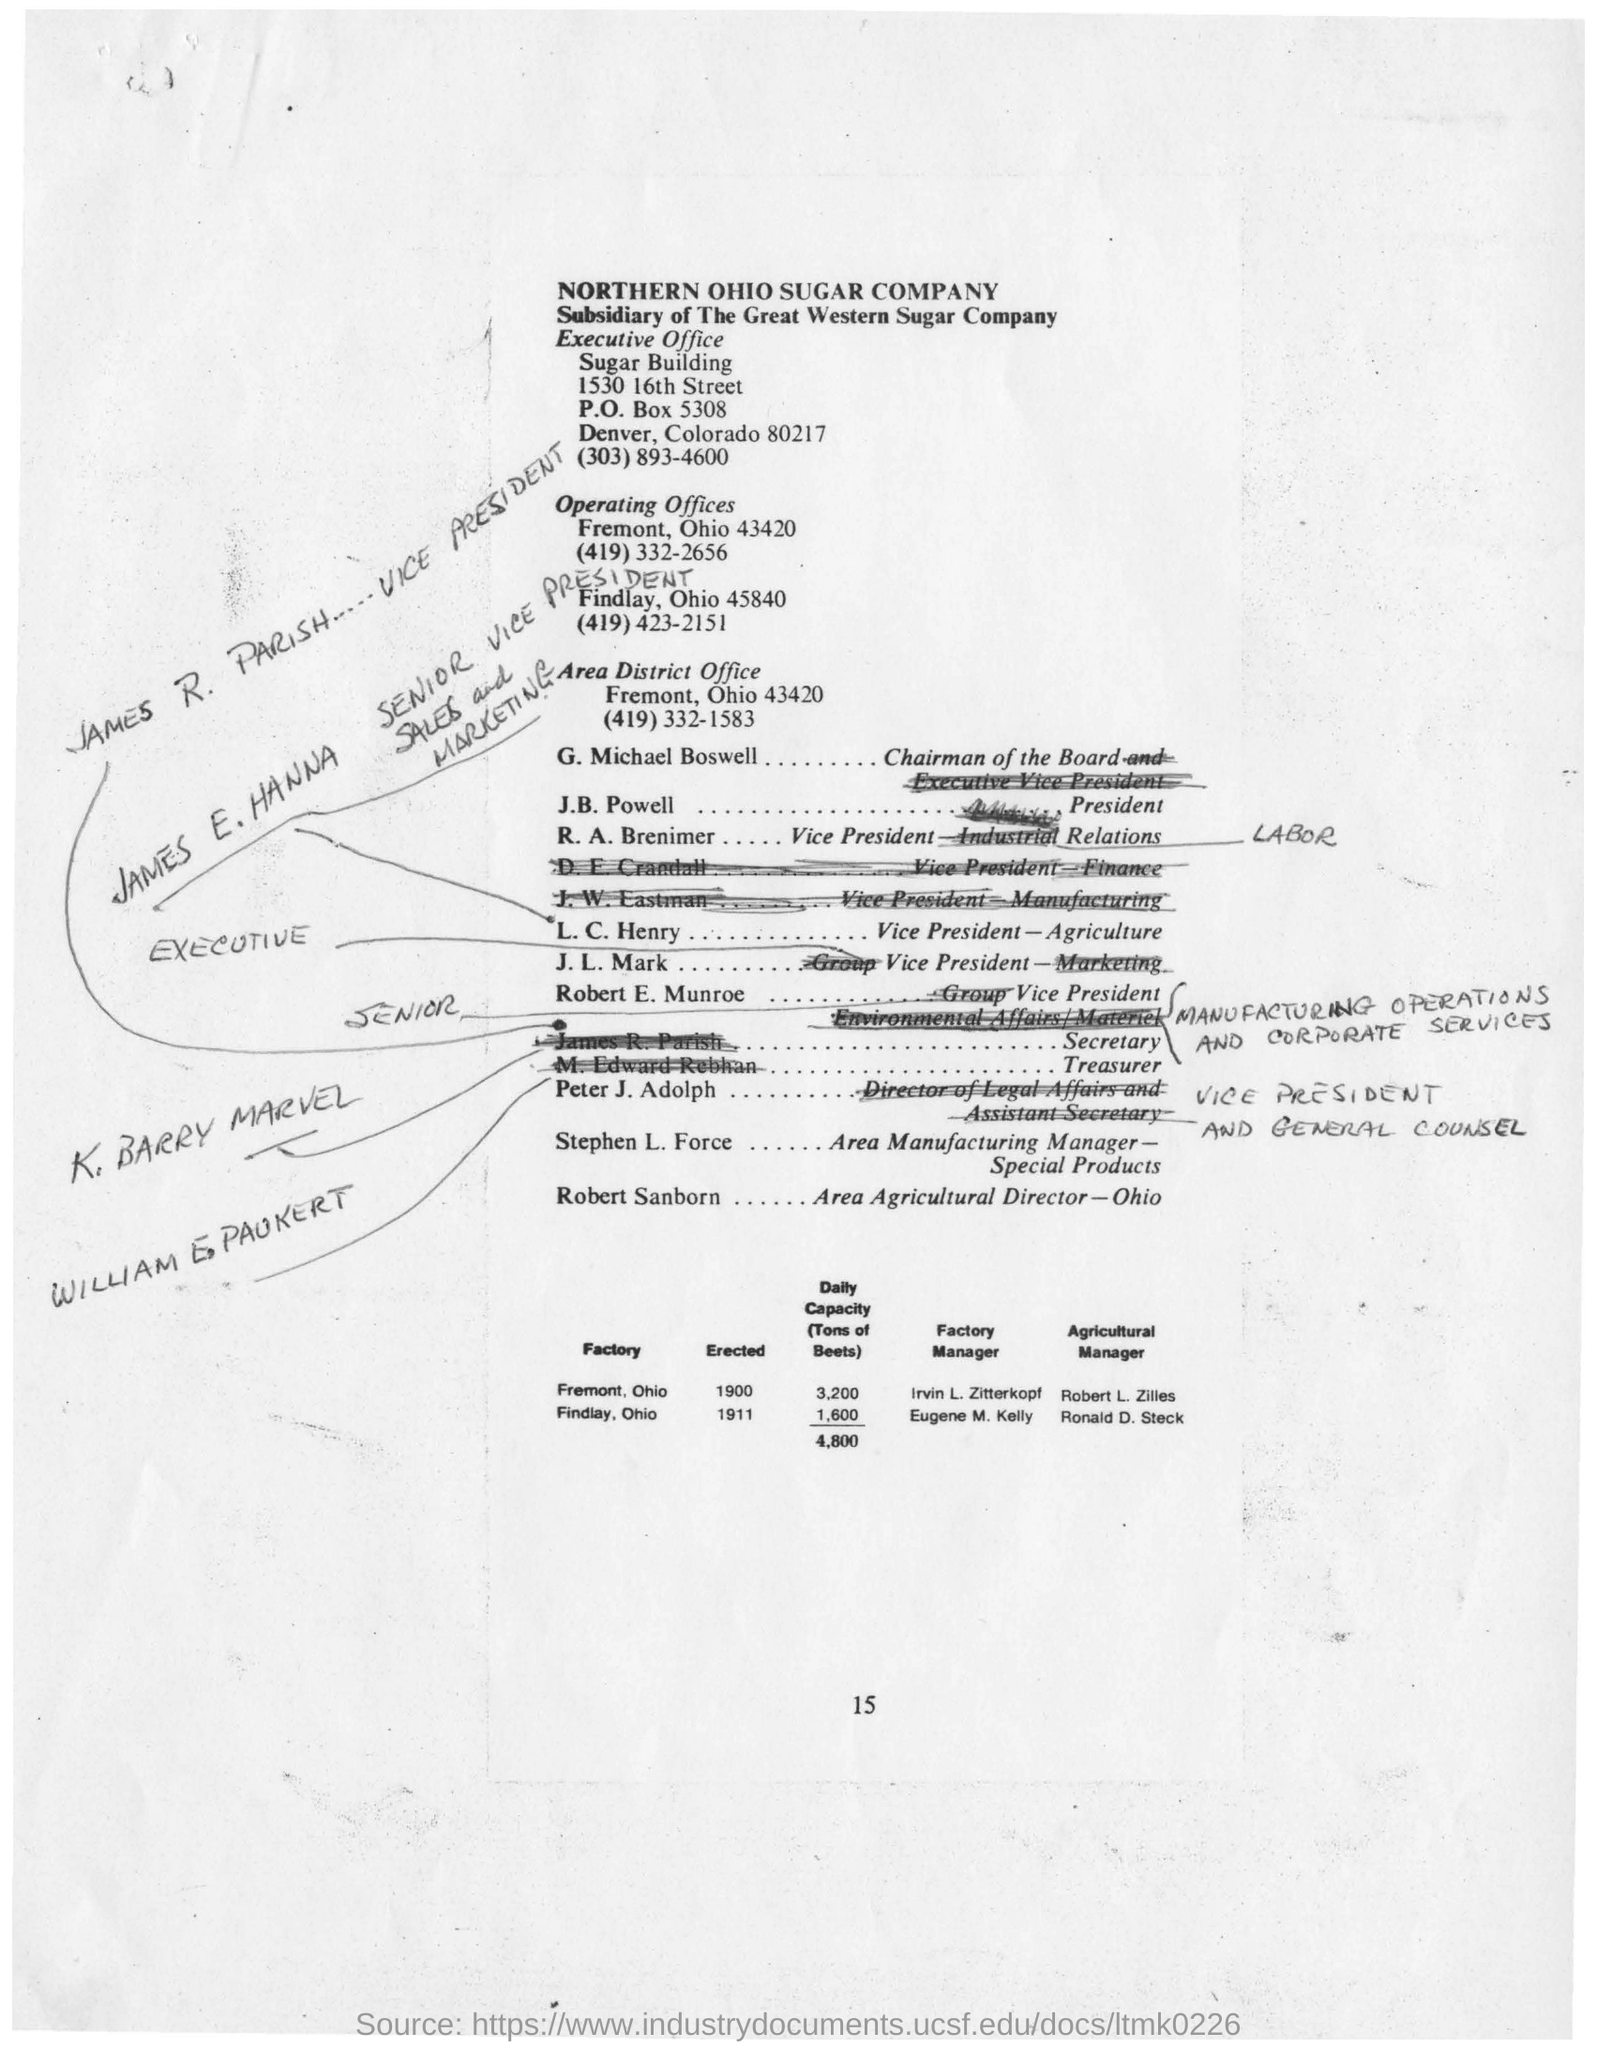Which company is the subsidiary of The Great Western Sugar Company?
Provide a short and direct response. Northern Ohio Sugar Company. What is the telephone number of the Executive Office?
Your answer should be compact. (303)893-4600. Where is Area District Office located?
Keep it short and to the point. Fremont, Ohio. Who is the Chairman of the Board?
Offer a very short reply. G. Michael Boswell. 